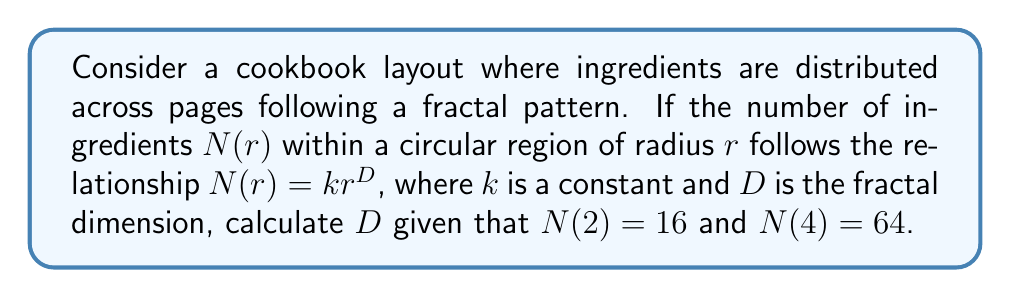Solve this math problem. To solve this problem, we'll follow these steps:

1) The fractal dimension $D$ is given by the relationship:

   $$N(r) = kr^D$$

2) We have two data points:
   
   $$N(2) = 16$$
   $$N(4) = 64$$

3) Let's apply the fractal dimension equation to both data points:

   $$16 = k(2)^D$$
   $$64 = k(4)^D$$

4) Divide the second equation by the first:

   $$\frac{64}{16} = \frac{k(4)^D}{k(2)^D}$$

5) The $k$ cancels out:

   $$4 = \left(\frac{4}{2}\right)^D = 2^D$$

6) Take the logarithm of both sides:

   $$\log_2(4) = \log_2(2^D)$$

7) Simplify:

   $$2 = D$$

Therefore, the fractal dimension $D$ is 2.
Answer: $D = 2$ 